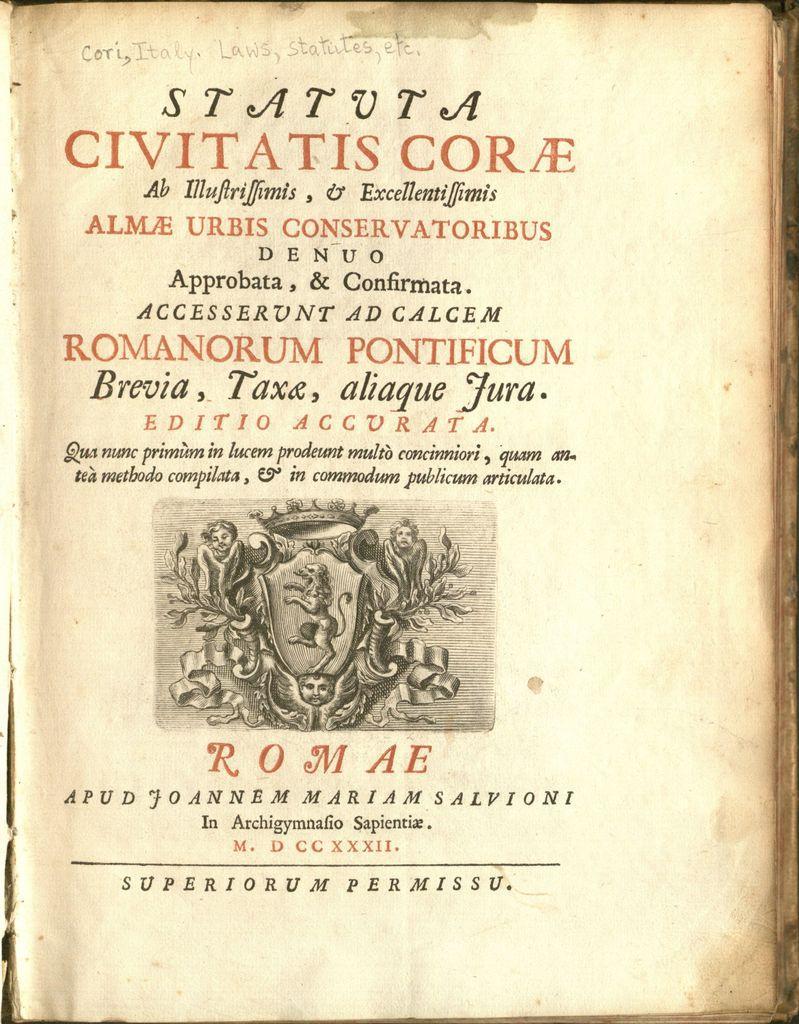Could you give a brief overview of what you see in this image? In this image we can see a page of the book. On the page we can see an image of a photo and some text written on it. 